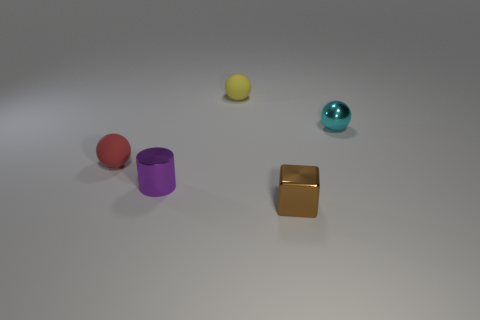Are there any purple metallic cylinders on the right side of the small matte ball that is to the left of the small purple metallic thing?
Offer a terse response. Yes. Are there fewer yellow balls that are to the right of the small shiny cylinder than balls behind the cyan shiny sphere?
Give a very brief answer. No. Are the sphere on the left side of the small shiny cylinder and the sphere that is right of the tiny shiny block made of the same material?
Your answer should be compact. No. What number of tiny objects are either red rubber spheres or yellow matte balls?
Offer a very short reply. 2. What shape is the tiny brown thing that is made of the same material as the purple thing?
Ensure brevity in your answer.  Cube. Are there fewer tiny cyan objects that are in front of the cyan sphere than cyan spheres?
Offer a very short reply. Yes. Do the small cyan object and the red object have the same shape?
Your answer should be very brief. Yes. What number of metallic things are either small spheres or big gray cylinders?
Offer a terse response. 1. Is there a blue matte cylinder that has the same size as the cyan shiny thing?
Your response must be concise. No. How many gray matte blocks have the same size as the red ball?
Make the answer very short. 0. 